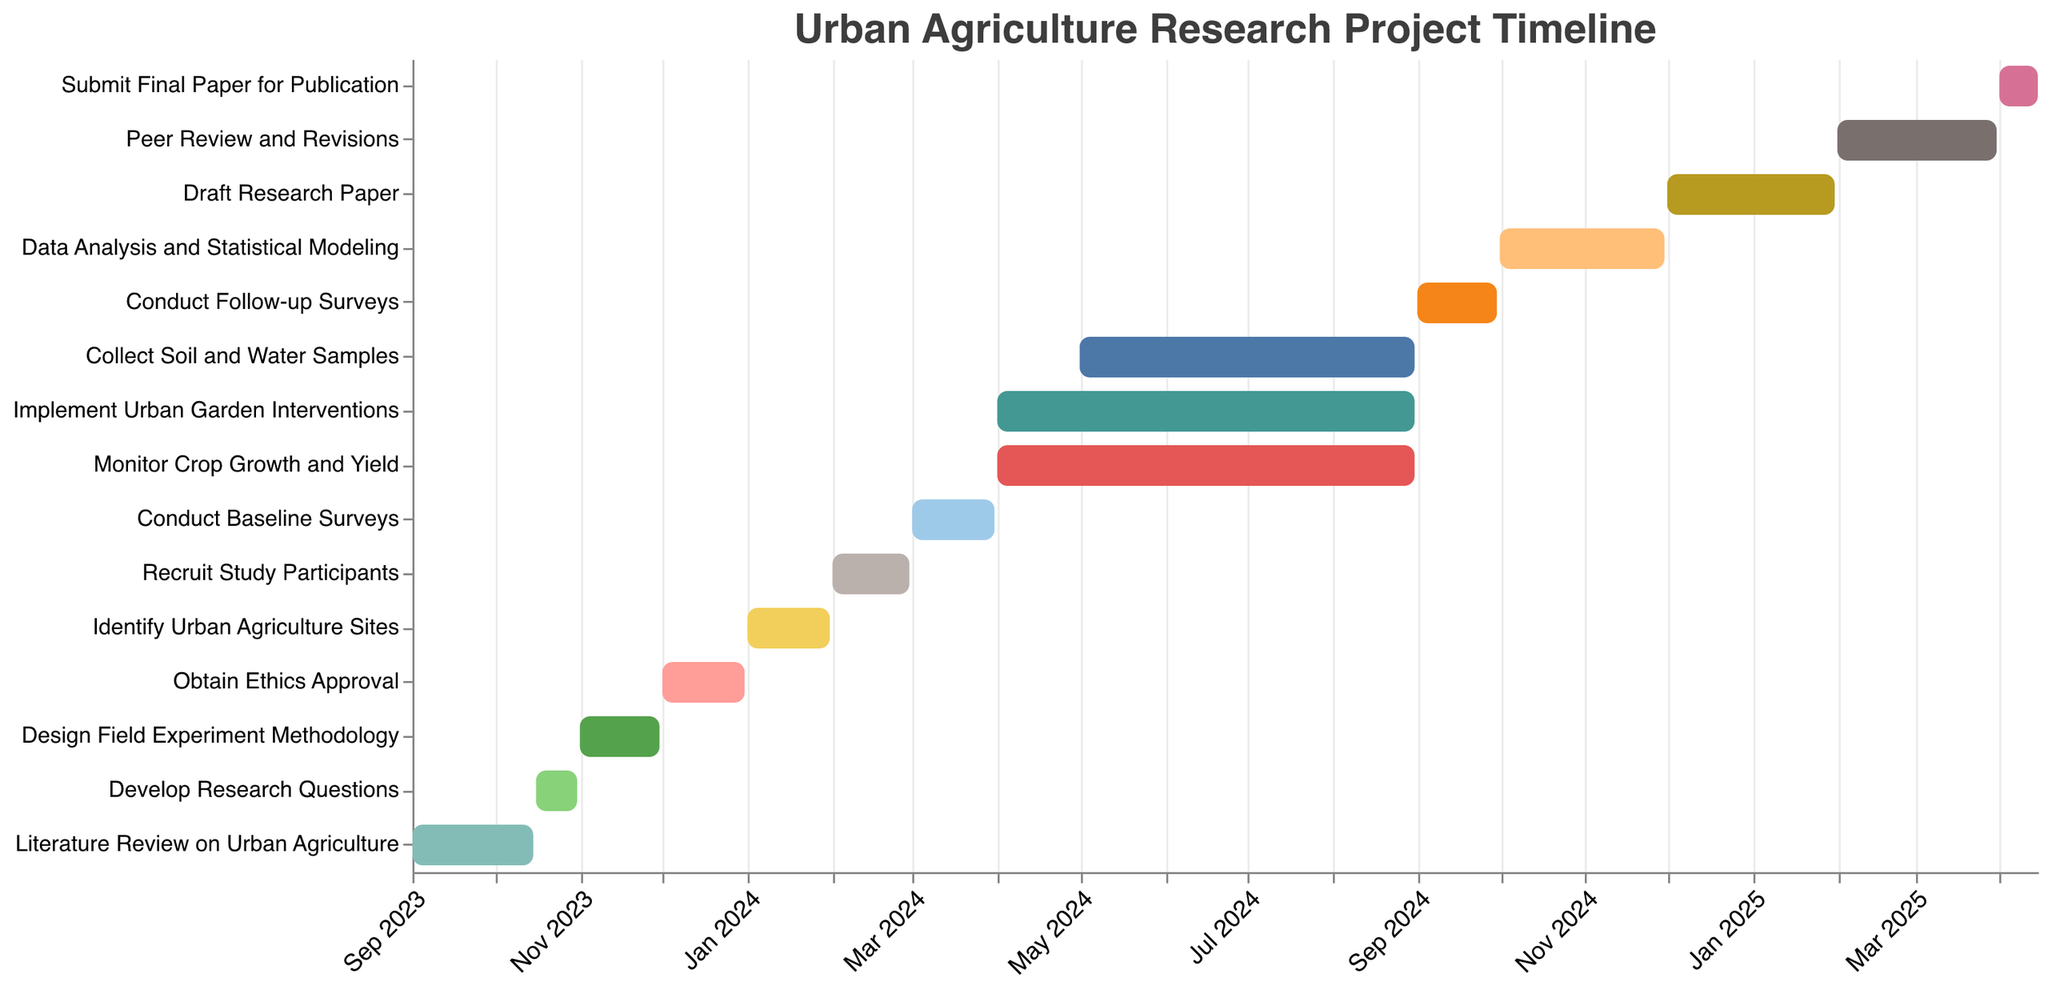What is the overall title of the Gantt Chart? The title is usually displayed prominently at the top of the chart. The title in this Gantt chart is "Urban Agriculture Research Project Timeline".
Answer: Urban Agriculture Research Project Timeline When does the "Literature Review on Urban Agriculture" task start and end? The "Literature Review on Urban Agriculture" task has start and end dates, which can be directly read from the data values displayed in the chart. It starts on "2023-09-01" and ends on "2023-10-15".
Answer: 2023-09-01 to 2023-10-15 Which tasks are carried out between "April 2024" and "August 2024"? To answer this, inspect the timeline and look for tasks that fall within or overlap with the specified date range. The tasks "Implement Urban Garden Interventions", "Monitor Crop Growth and Yield", and "Collect Soil and Water Samples" are carried out between "April 2024" and "August 2024".
Answer: Implement Urban Garden Interventions, Monitor Crop Growth and Yield, Collect Soil and Water Samples How long is the "Implement Urban Garden Interventions" task in months? The task duration can be calculated by considering the start and end dates. "Implement Urban Garden Interventions" starts on 2024-04-01 and ends on 2024-08-31. The task duration is 5 months (April to August inclusive).
Answer: 5 months Which task immediately follows "Develop Research Questions"? Determine the end date of "Develop Research Questions" and identify the task that starts right after that date. "Develop Research Questions" ends on 2023-10-31. The task that starts immediately after is "Design Field Experiment Methodology" on 2023-11-01.
Answer: Design Field Experiment Methodology What is the duration of the "Peer Review and Revisions" task? The duration can be found by calculating the difference between the start and end dates. "Peer Review and Revisions" starts on 2025-02-01 and ends on 2025-03-31. This results in a duration of roughly 2 months.
Answer: 2 months How many tasks overlap during the period from "May 2024" to "August 2024"? To solve this, identify the tasks whose timelines include or intersect with the period from "May 2024" to "August 2024". The tasks overlapping during this period are "Implement Urban Garden Interventions", "Monitor Crop Growth and Yield", and "Collect Soil and Water Samples".
Answer: 3 tasks Which task has the shortest duration, and how long is it? To determine the shortest task, assess the duration of each task by comparing their start and end dates. "Develop Research Questions" runs from 2023-10-16 to 2023-10-31, which is roughly 15 days, making it the shortest task.
Answer: Develop Research Questions, 15 days What tasks run concurrently with "Conduct Baseline Surveys"? Identify tasks that overlap with the duration of "Conduct Baseline Surveys," which runs from 2024-03-01 to 2024-03-31. However, none of the other tasks overlap with this specific time period, so "Conduct Baseline Surveys" runs alone during its timeframe.
Answer: None When is the project planned for final paper submission? Look for the task named "Submit Final Paper for Publication" and read its timeline for the exact end date. "Submit Final Paper for Publication" has an end date of 2025-04-15.
Answer: 2025-04-15 